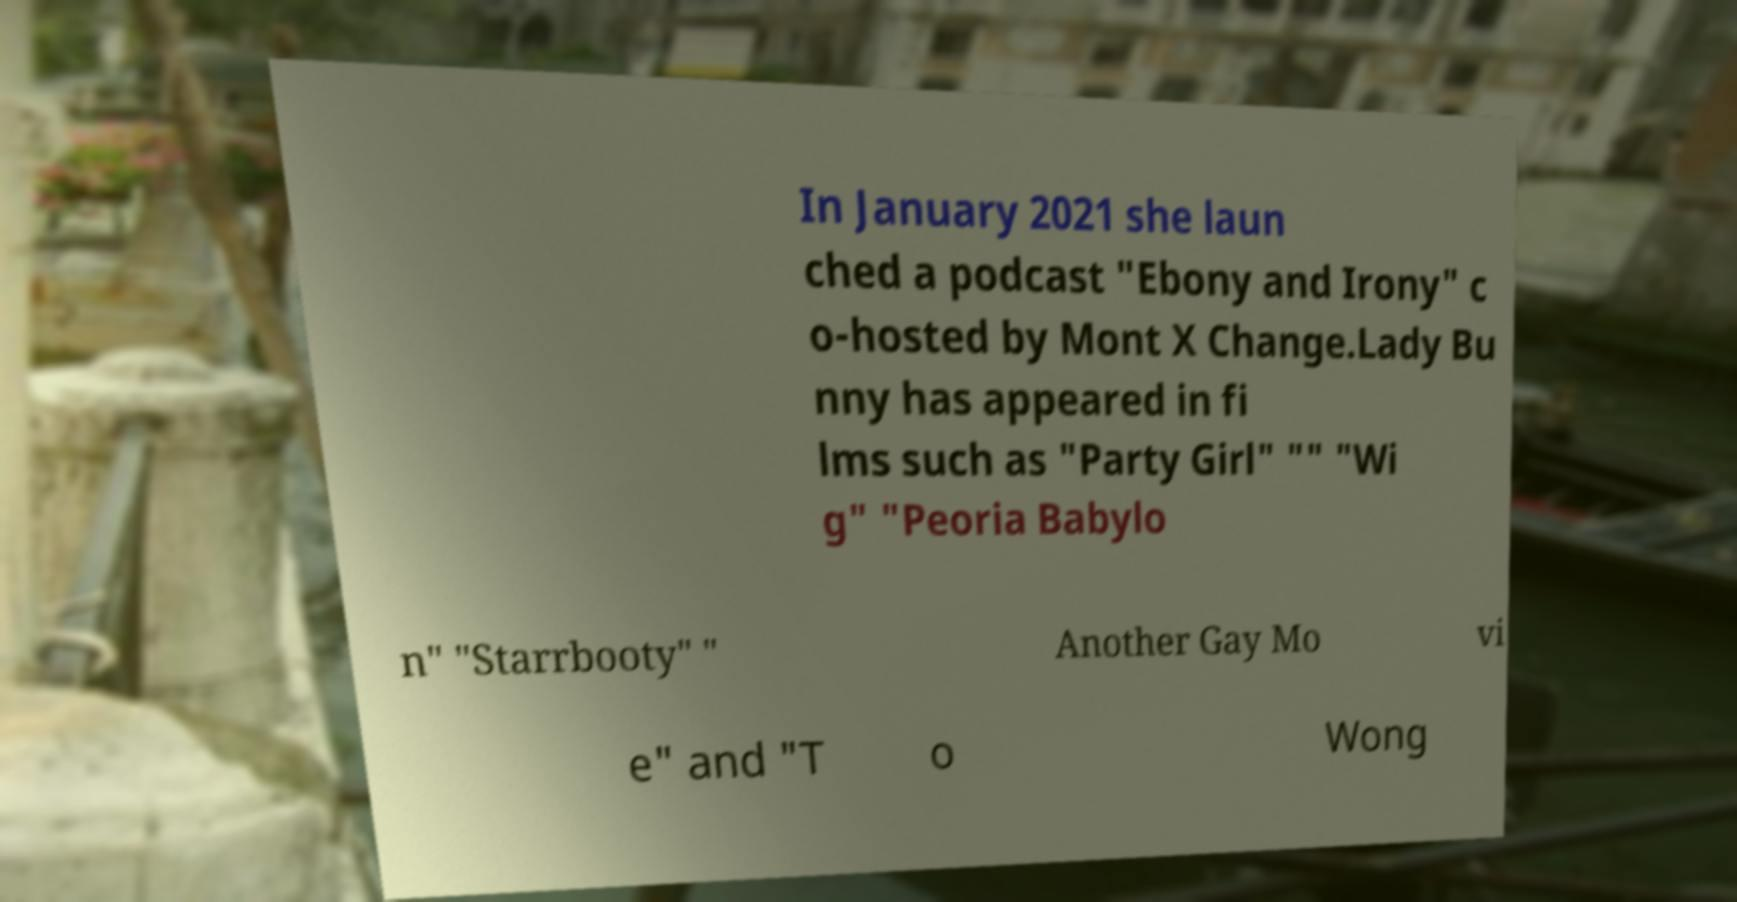Can you read and provide the text displayed in the image?This photo seems to have some interesting text. Can you extract and type it out for me? In January 2021 she laun ched a podcast "Ebony and Irony" c o-hosted by Mont X Change.Lady Bu nny has appeared in fi lms such as "Party Girl" "" "Wi g" "Peoria Babylo n" "Starrbooty" " Another Gay Mo vi e" and "T o Wong 